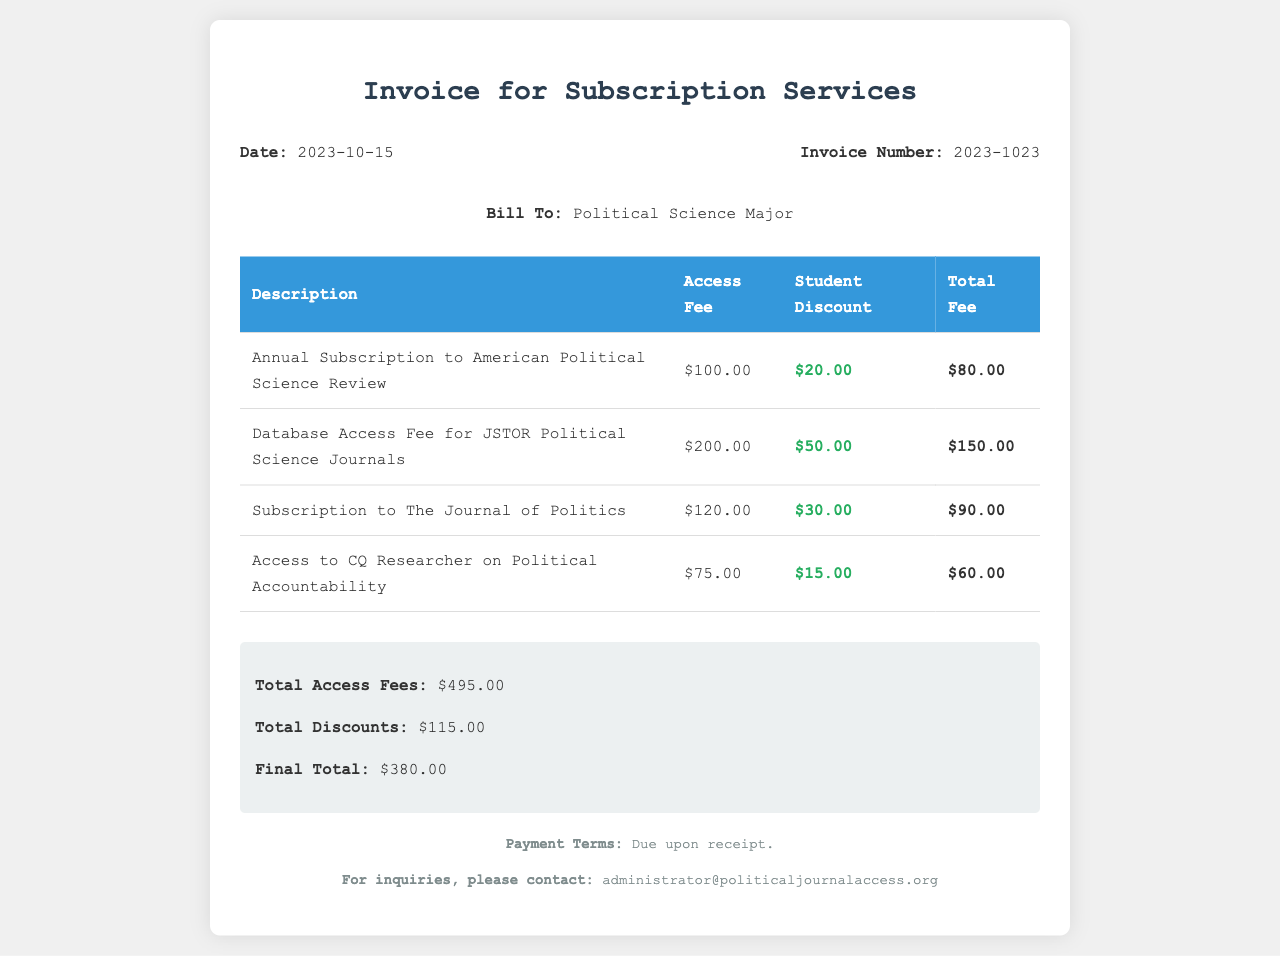What is the invoice number? The invoice number is specified in the document under "Invoice Number."
Answer: 2023-1023 What is the total fee for the subscription to The Journal of Politics? The total fee for The Journal of Politics is given in the corresponding table row.
Answer: $90.00 How much is the student discount for the database access fee for JSTOR Political Science Journals? The student discount for the JSTOR database access fee can be found in the table.
Answer: $50.00 What is the total access fees amount? The total access fees are listed in the summary section of the document.
Answer: $495.00 What is the final total after applying discounts? The final total is provided in the summary section of the invoice.
Answer: $380.00 When is the payment due? The payment terms indicate the due date and can be found in the footer of the document.
Answer: Due upon receipt 